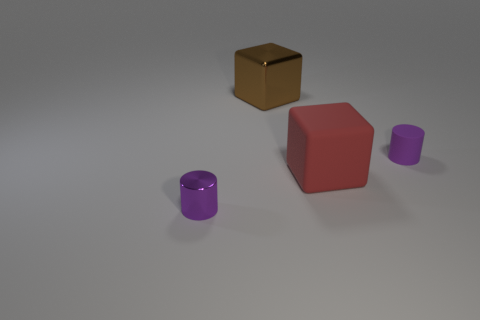Can you describe the shapes and colors of the objects in this image? Certainly! There are three distinct objects: a small purple cylinder, a larger red cube, and a gold-colored box. The purple cylinder and red cube have a matte surface, while the gold box has a shiny, reflective surface. 